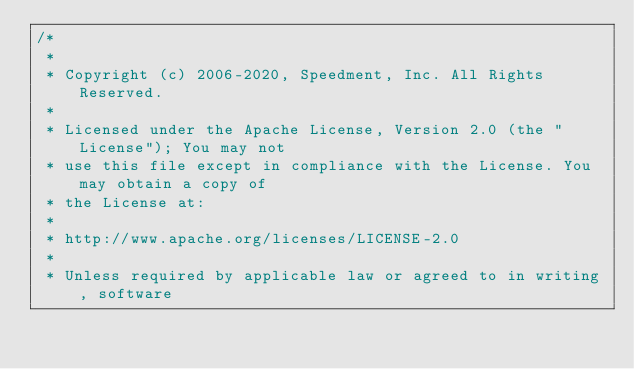Convert code to text. <code><loc_0><loc_0><loc_500><loc_500><_Java_>/*
 *
 * Copyright (c) 2006-2020, Speedment, Inc. All Rights Reserved.
 *
 * Licensed under the Apache License, Version 2.0 (the "License"); You may not
 * use this file except in compliance with the License. You may obtain a copy of
 * the License at:
 *
 * http://www.apache.org/licenses/LICENSE-2.0
 *
 * Unless required by applicable law or agreed to in writing, software</code> 